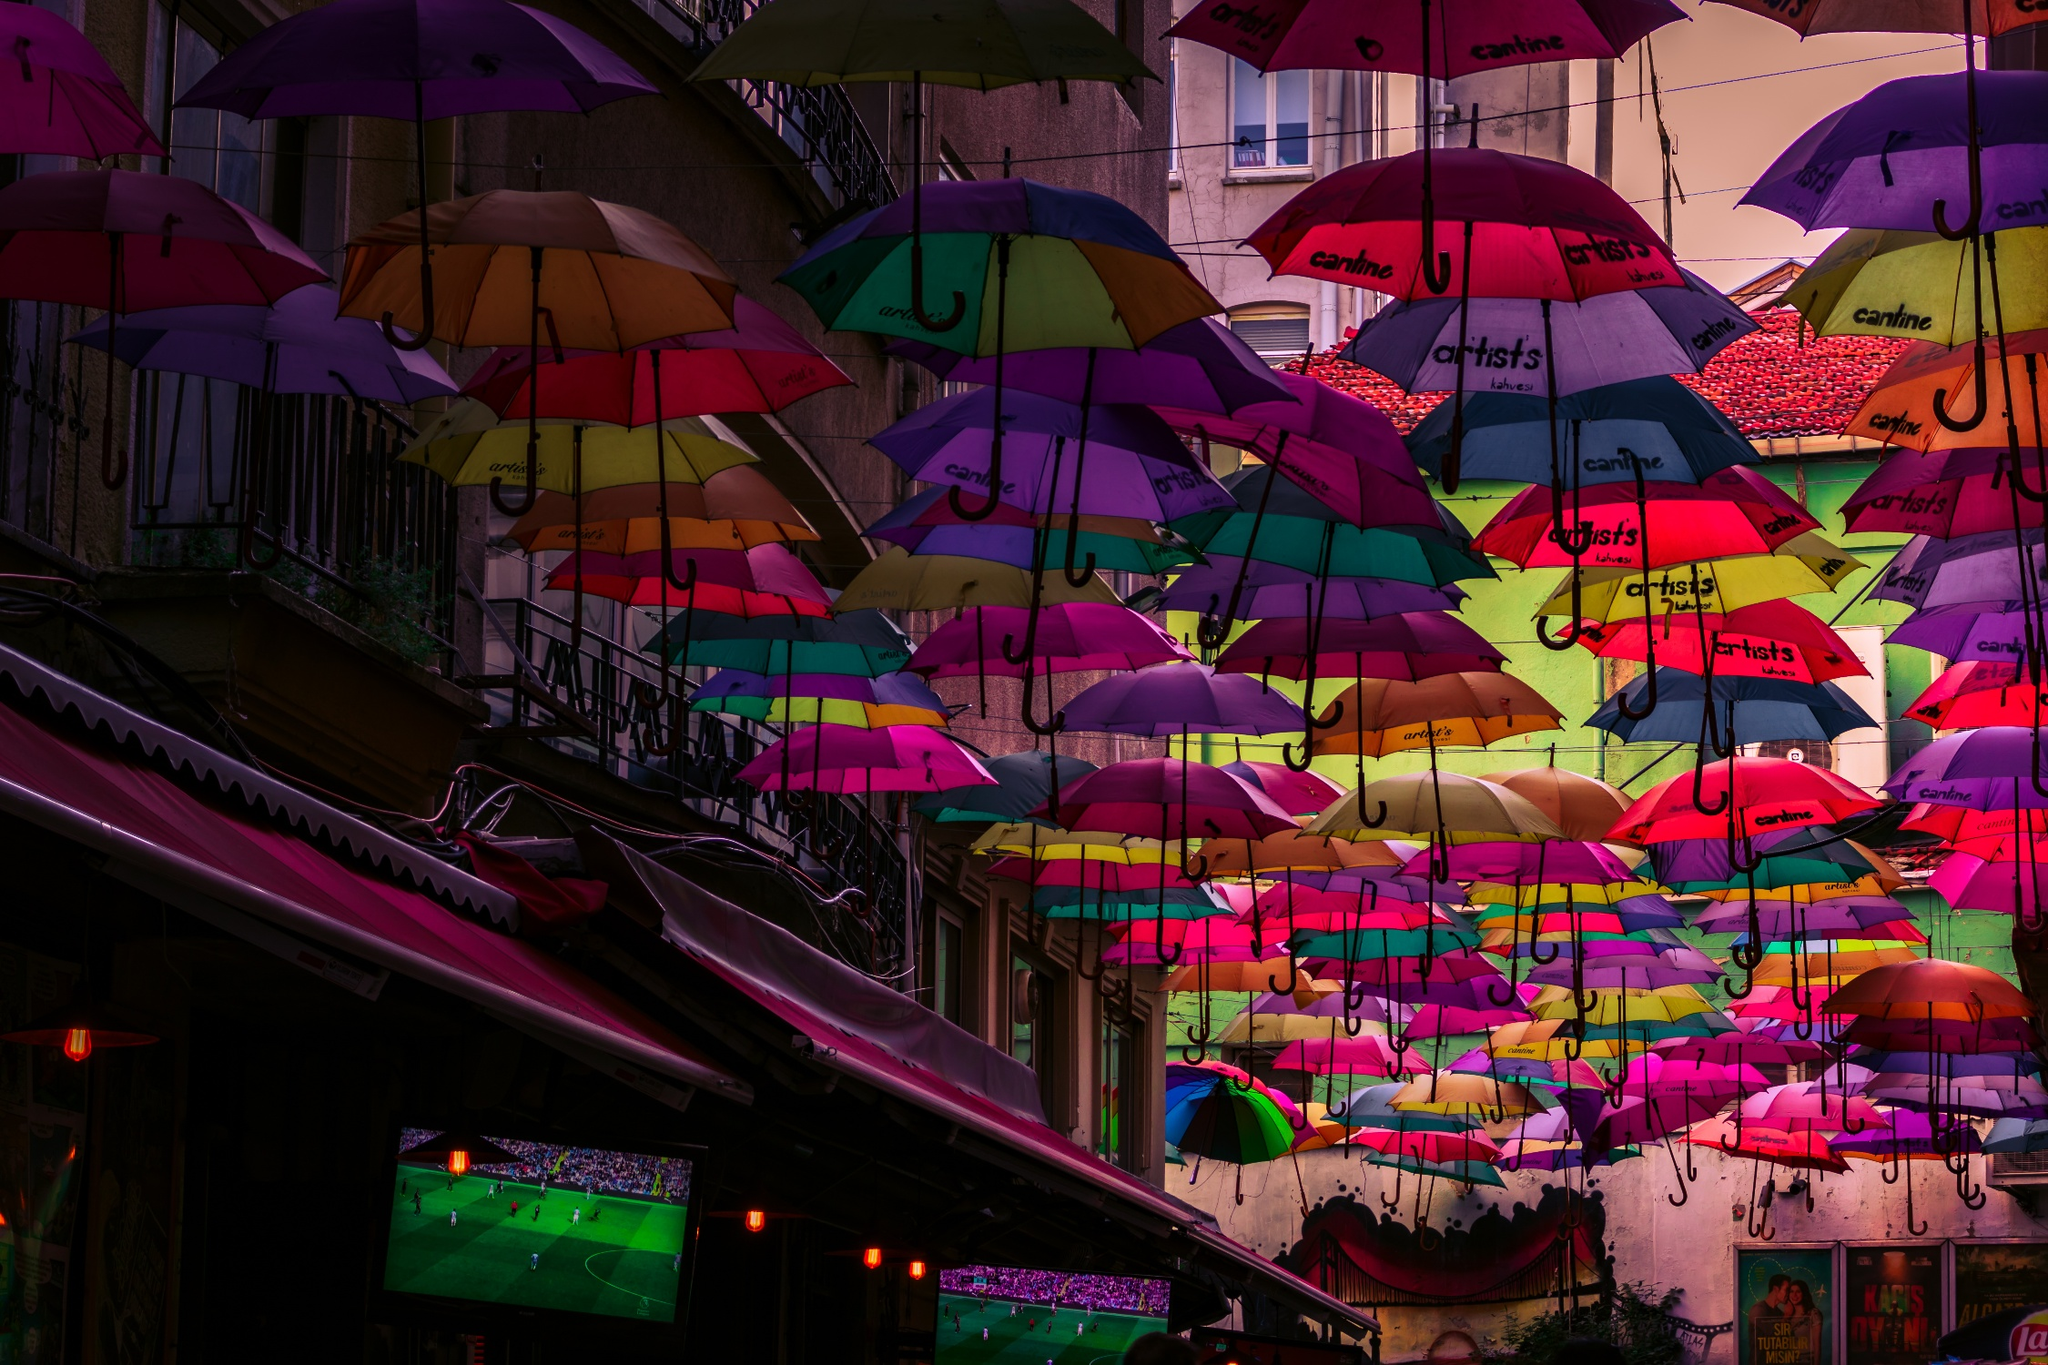Can you describe an artistic festival or event that features similar umbrella displays? One prominent example of a festival that features similar umbrella displays is the 'AgitÁgueda' Art Festival in Águeda, Portugal. Held every July, this annual event is famous for its vibrant umbrella sky project, where colorful umbrellas are suspended above the streets, creating a stunning canopy. This art installation not only brings life and color to the town but also offers a playful twist that attracts numerous visitors. Besides the umbrella displays, the festival also includes street art, live music, performances, and various cultural activities that celebrate creativity and community spirit. How does the 'AgitÁgueda' Art Festival benefit the local community? The 'AgitÁgueda' Art Festival benefits the local community in several ways. Economically, it draws thousands of visitors, which boosts local businesses, including hotels, restaurants, and shops. Cultural exchanges and performances bring artists and audiences together, fostering a vibrant art scene and a deeper appreciation of the arts. Socially, the festival promotes a sense of community, bringing residents together to participate in and enjoy various activities. It also enhances the town's reputation as a cultural destination, encouraging year-round tourism. Moreover, the event provides a platform for local artists to showcase their work, supporting the town's creative economy. Imagine if these umbrellas could generate energy. How would that change the purpose of such installations? If these umbrellas were capable of generating energy, their purpose would expand beyond cultural and aesthetic roles to include environmental and technological functions. Imagine each umbrella fitted with solar panels or mini-wind turbines. Not only would they continue to beautify public spaces and draw crowds, but they would also contribute to sustainable energy generation. This dual functionality could turn artistic installations into practical utilities, helping to power local streetlights, public facilities, and even nearby businesses. Such innovation would highlight the integration of art and technology, setting a precedent for environmentally-conscious urban planning and design. Moreover, this concept could inspire educational initiatives, teaching communities about renewable energy sources and sustainable practices through interactive art. 